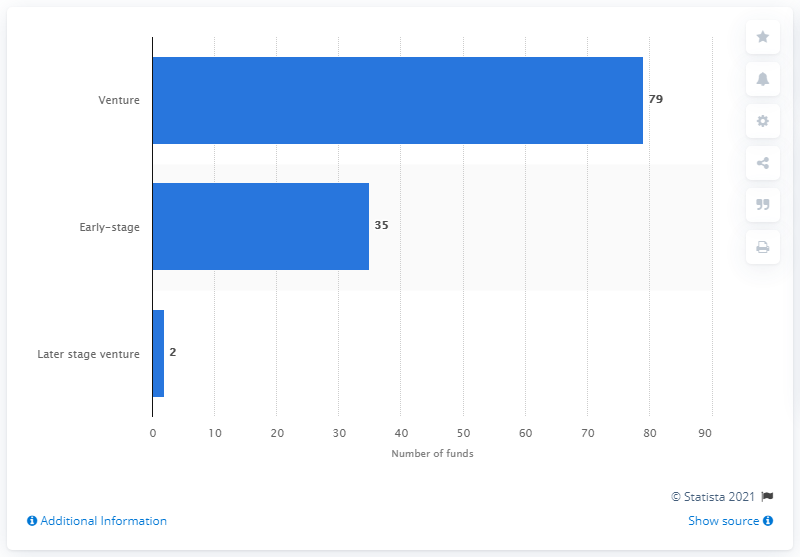List a handful of essential elements in this visual. As of 2016, there were 35 operational early stage venture capital private equity funds in Europe. 